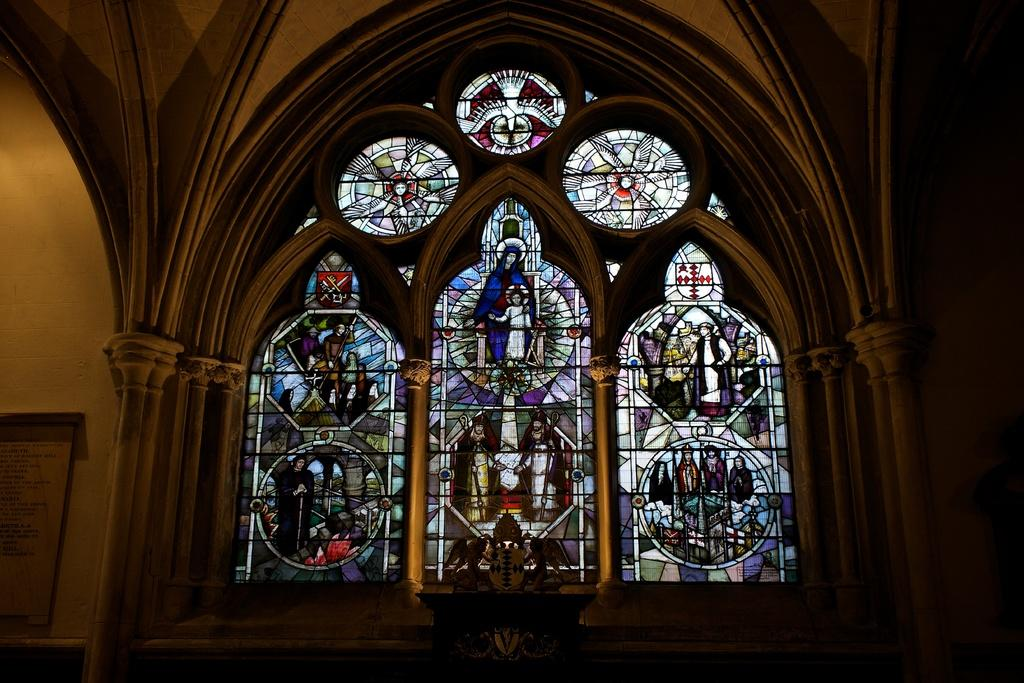What type of structure can be seen in the image? There is a wall in the image. What is attached to the wall? There is a text board in the image. What kind of window is present in the image? There is a window with stained glass in the image. What is located at the bottom of the image? There is an object at the bottom of the image. How many tails can be seen on the birds in the image? There are no birds present in the image, so it is not possible to determine the number of tails. What type of machine is visible in the image? There is no machine visible in the image; it features a wall, text board, window with stained glass, and an object at the bottom. 